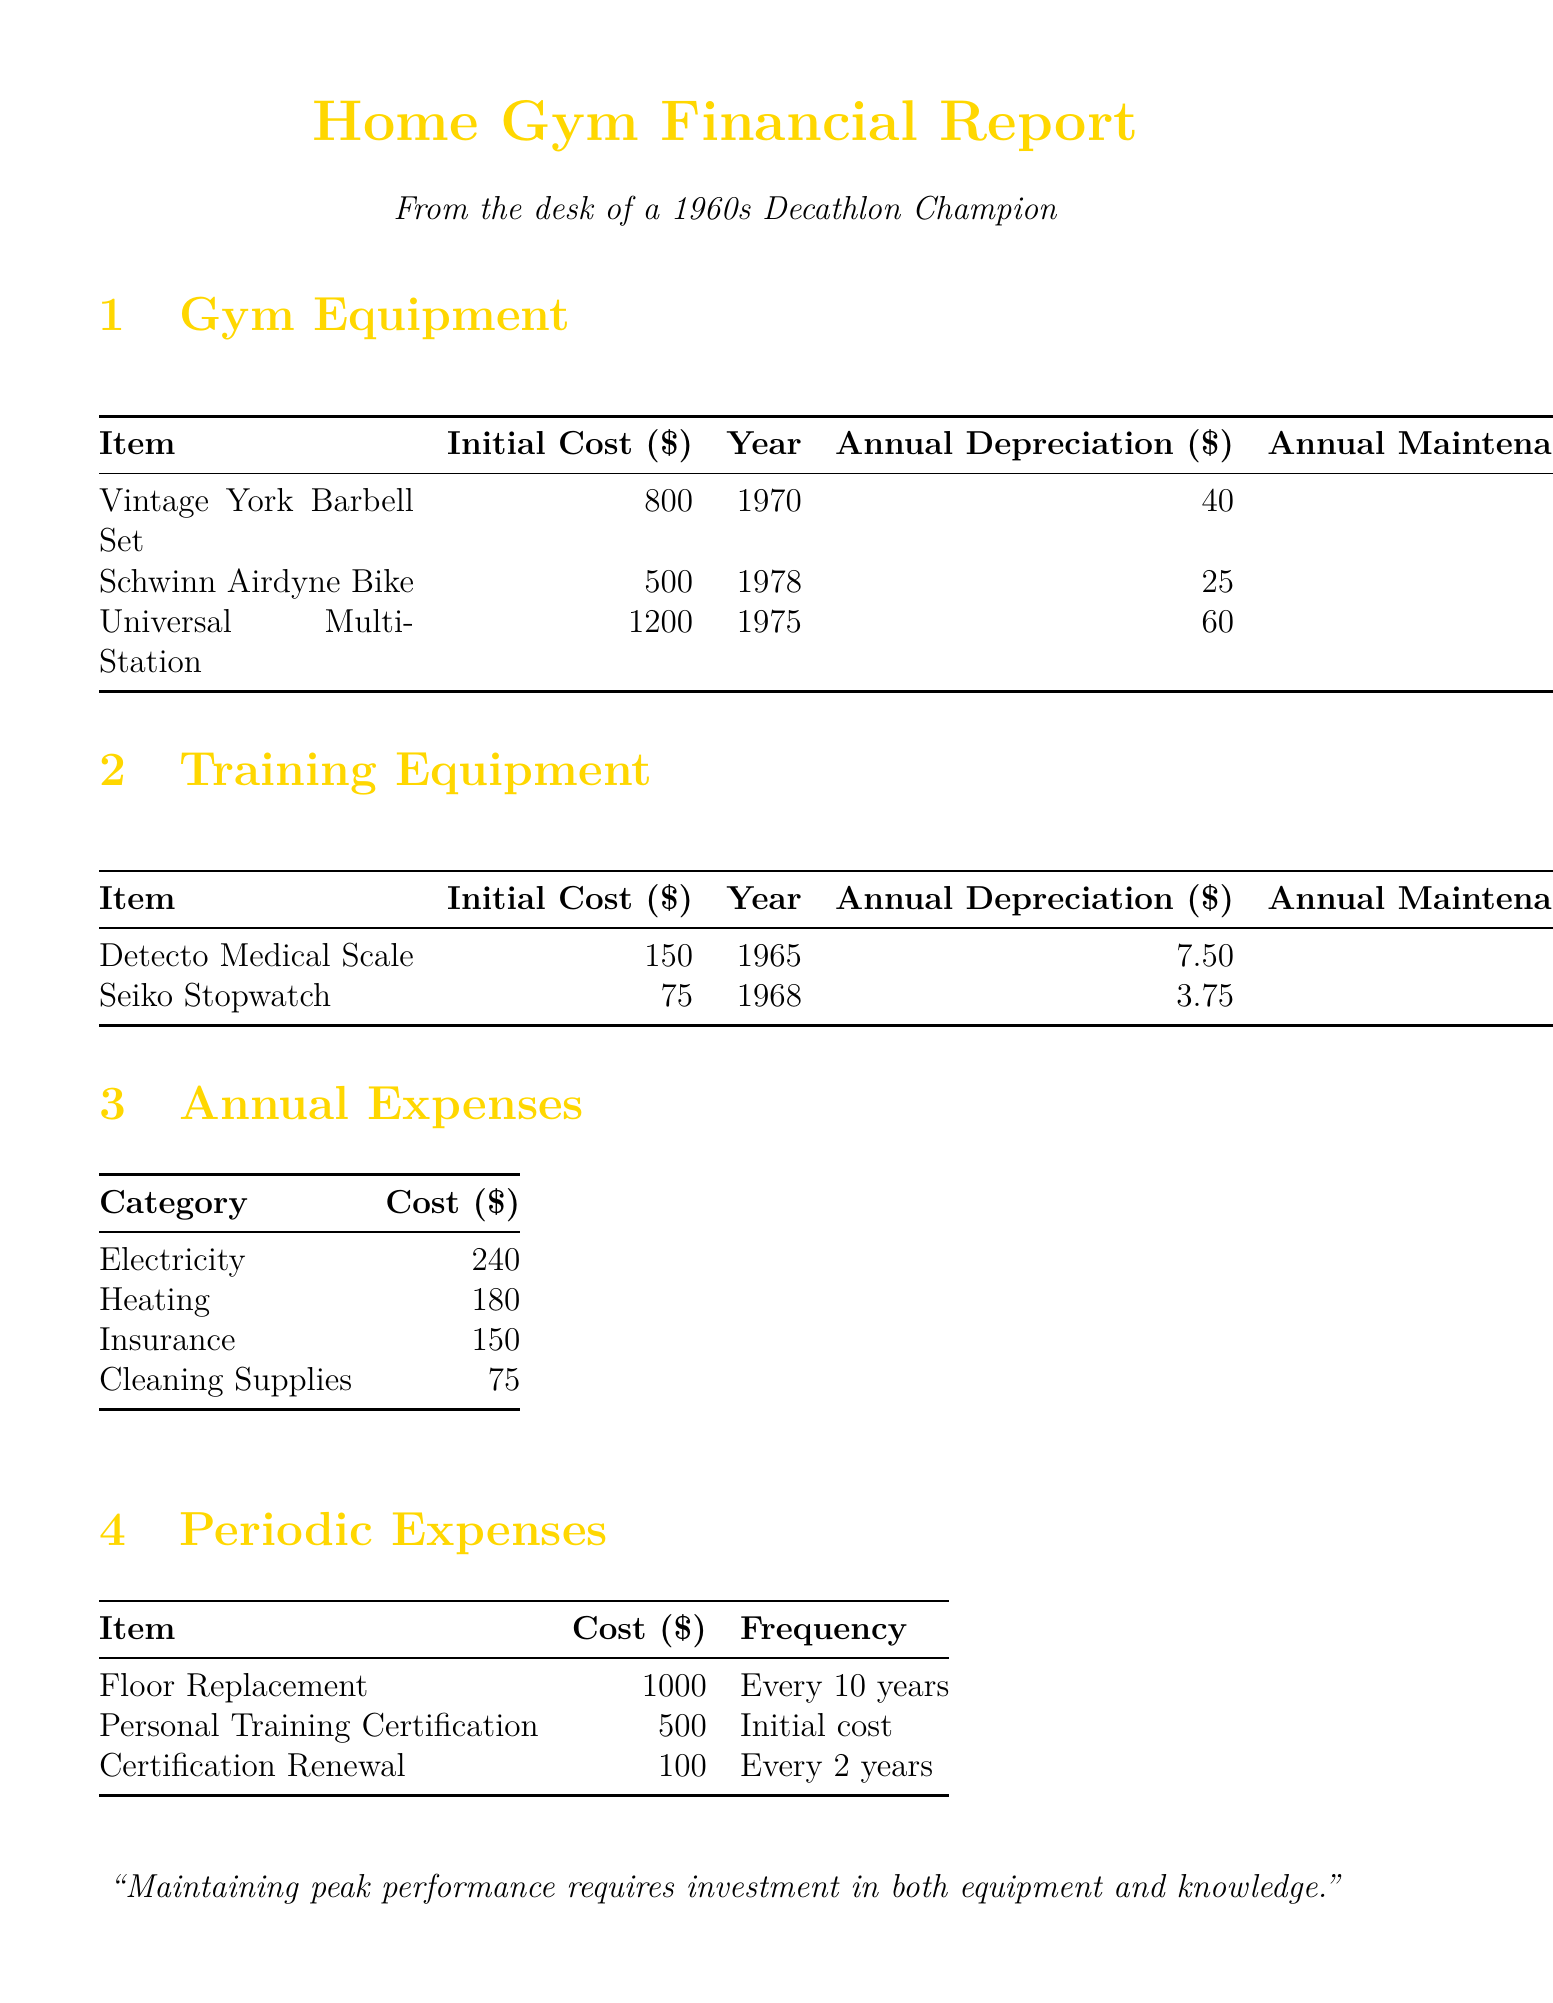what is the initial cost of the Universal Multi-Station Gym? The initial cost of the Universal Multi-Station Gym is listed in the gym equipment section, which is $1200.
Answer: $1200 how much is the annual maintenance cost for the Schwinn Airdyne Exercise Bike? The annual maintenance cost for the Schwinn Airdyne Exercise Bike is specified in the gym equipment section, which is $30.
Answer: $30 in what year was the Detecto Medical Scale purchased? The year of purchase for the Detecto Medical Scale can be found in the training equipment section, which is 1965.
Answer: 1965 what is the frequency of the floor replacement expense? The frequency for floor replacement is stated in the periodic expenses section, which is every 10 years.
Answer: Every 10 years what is the total annual cost for electricity and heating? The total annual cost for electricity and heating is calculated by adding their respective costs, which are $240 and $180, totaling $420.
Answer: $420 how much does the personal training certification renewal cost? The document indicates the renewal cost for personal training certification in the periodic expenses section, which is $100.
Answer: $100 what is the total initial cost of gym equipment listed? The total initial cost is the summation of the initial costs of all gym equipment, which totals $2500 ($800 + $500 + $1200).
Answer: $2500 how much is the annual insurance premium? The annual insurance premium is provided in the annual expenses section as $150.
Answer: $150 which gym equipment has the highest annual depreciation? The highest annual depreciation among the gym equipment listed is that of the Universal Multi-Station Gym at $60.
Answer: $60 